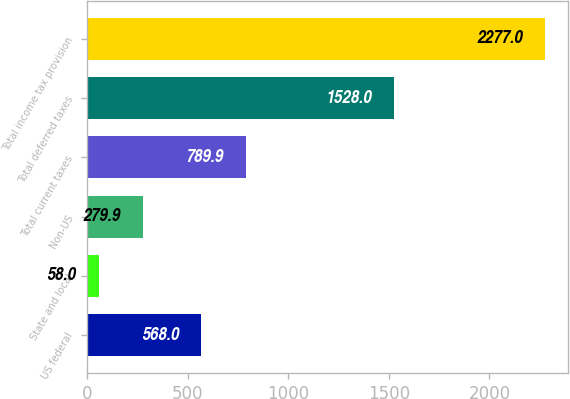<chart> <loc_0><loc_0><loc_500><loc_500><bar_chart><fcel>US federal<fcel>State and local<fcel>Non-US<fcel>Total current taxes<fcel>Total deferred taxes<fcel>Total income tax provision<nl><fcel>568<fcel>58<fcel>279.9<fcel>789.9<fcel>1528<fcel>2277<nl></chart> 